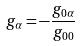Convert formula to latex. <formula><loc_0><loc_0><loc_500><loc_500>g _ { \alpha } = - \frac { g _ { 0 \alpha } } { g _ { 0 0 } }</formula> 